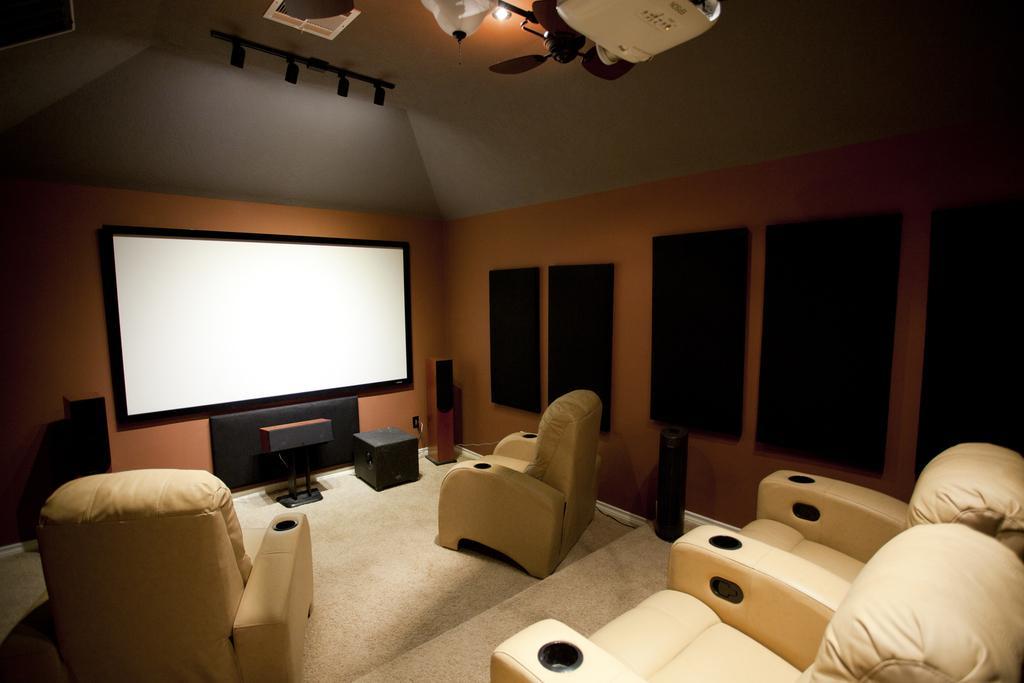Can you describe this image briefly? This picture is an inside view of a room. In this picture we can see the chairs, floor, table speakers, screen, wall, boards. At the top of the image we can see the roof, chandelier, light and projector. 